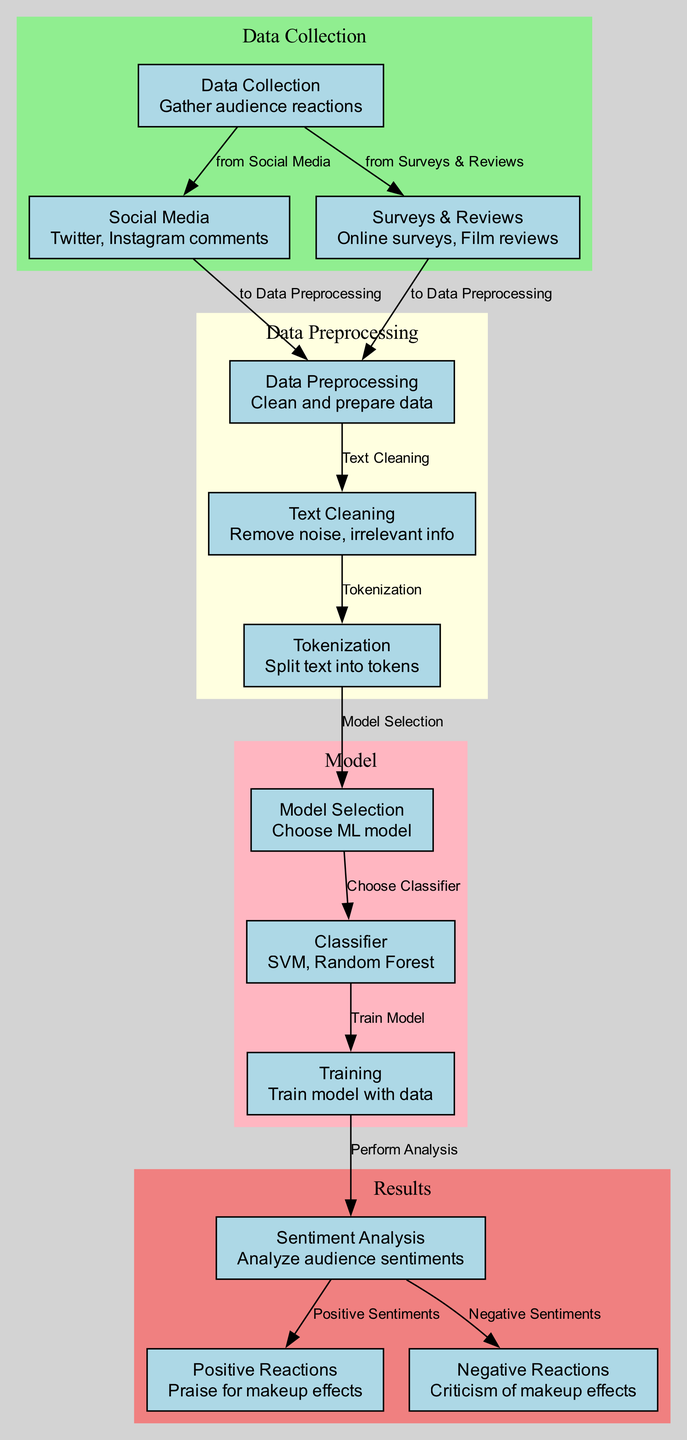What are the sources for data collection? The diagram shows two main sources for data collection: "Social Media" and "Surveys & Reviews", which are depicted as nodes connected to the "Data Collection" node.
Answer: Social Media, Surveys & Reviews How many nodes are there in the diagram? By counting each unique node listed, there are a total of 12 nodes included in the diagram, indicating the different processes involved in the sentiment analysis.
Answer: 12 What is the result of the sentiment analysis? The output of the "Sentiment Analysis" node includes two branches: "Positive Reactions" and "Negative Reactions", showcasing the dual nature of audience sentiment.
Answer: Positive Reactions, Negative Reactions What type of classifiers are mentioned in the diagram? The diagram specifies "SVM" and "Random Forest" as the types of classifiers that can be selected under the "Classifier" node in the model selection process.
Answer: SVM, Random Forest What node follows text cleaning? According to the sequence in the diagram, the node that follows "Text Cleaning" is "Tokenization", indicating the next step in data preprocessing.
Answer: Tokenization Which node represents the analysis of audience sentiments? The node titled "Sentiment Analysis" explicitly represents the analysis of audience sentiments after the training phase is complete.
Answer: Sentiment Analysis What first occurs in the process of sentiment analysis? The first occurrence in the sentiment analysis process is the "Data Collection" from various sources, as indicated by the starting point of the diagram.
Answer: Data Collection What is the purpose of the "Data Preprocessing" node? "Data Preprocessing" is aimed at preparing the audience reaction data for sentiment analysis, involving methods such as text cleaning and tokenization, which are steps leading from the raw data sources.
Answer: Prepare data What are the two outcomes of the sentiment analysis? The two outcomes are categorized into "Positive Reactions" signifying praise and "Negative Reactions" indicating criticism of the makeup effects, as shown at the end of the analysis flow.
Answer: Positive Reactions, Negative Reactions 